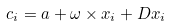Convert formula to latex. <formula><loc_0><loc_0><loc_500><loc_500>c _ { i } = a + \omega \times x _ { i } + D x _ { i }</formula> 